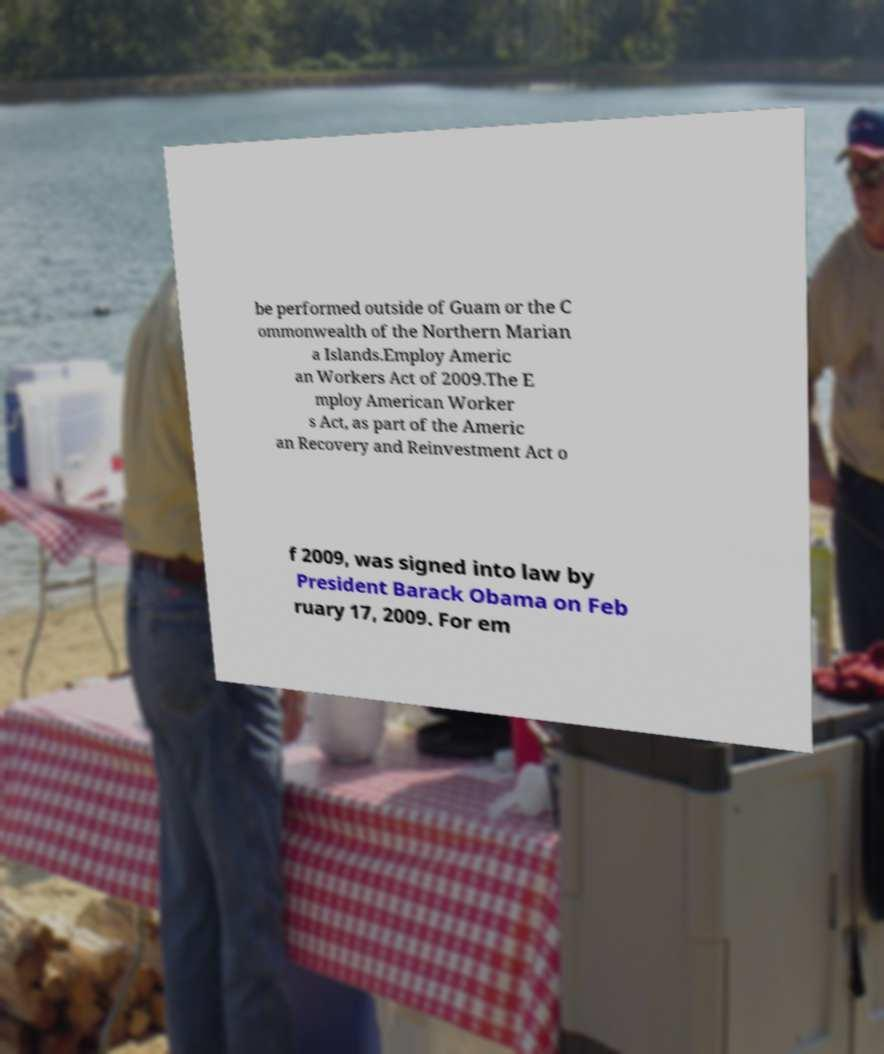What messages or text are displayed in this image? I need them in a readable, typed format. be performed outside of Guam or the C ommonwealth of the Northern Marian a Islands.Employ Americ an Workers Act of 2009.The E mploy American Worker s Act, as part of the Americ an Recovery and Reinvestment Act o f 2009, was signed into law by President Barack Obama on Feb ruary 17, 2009. For em 